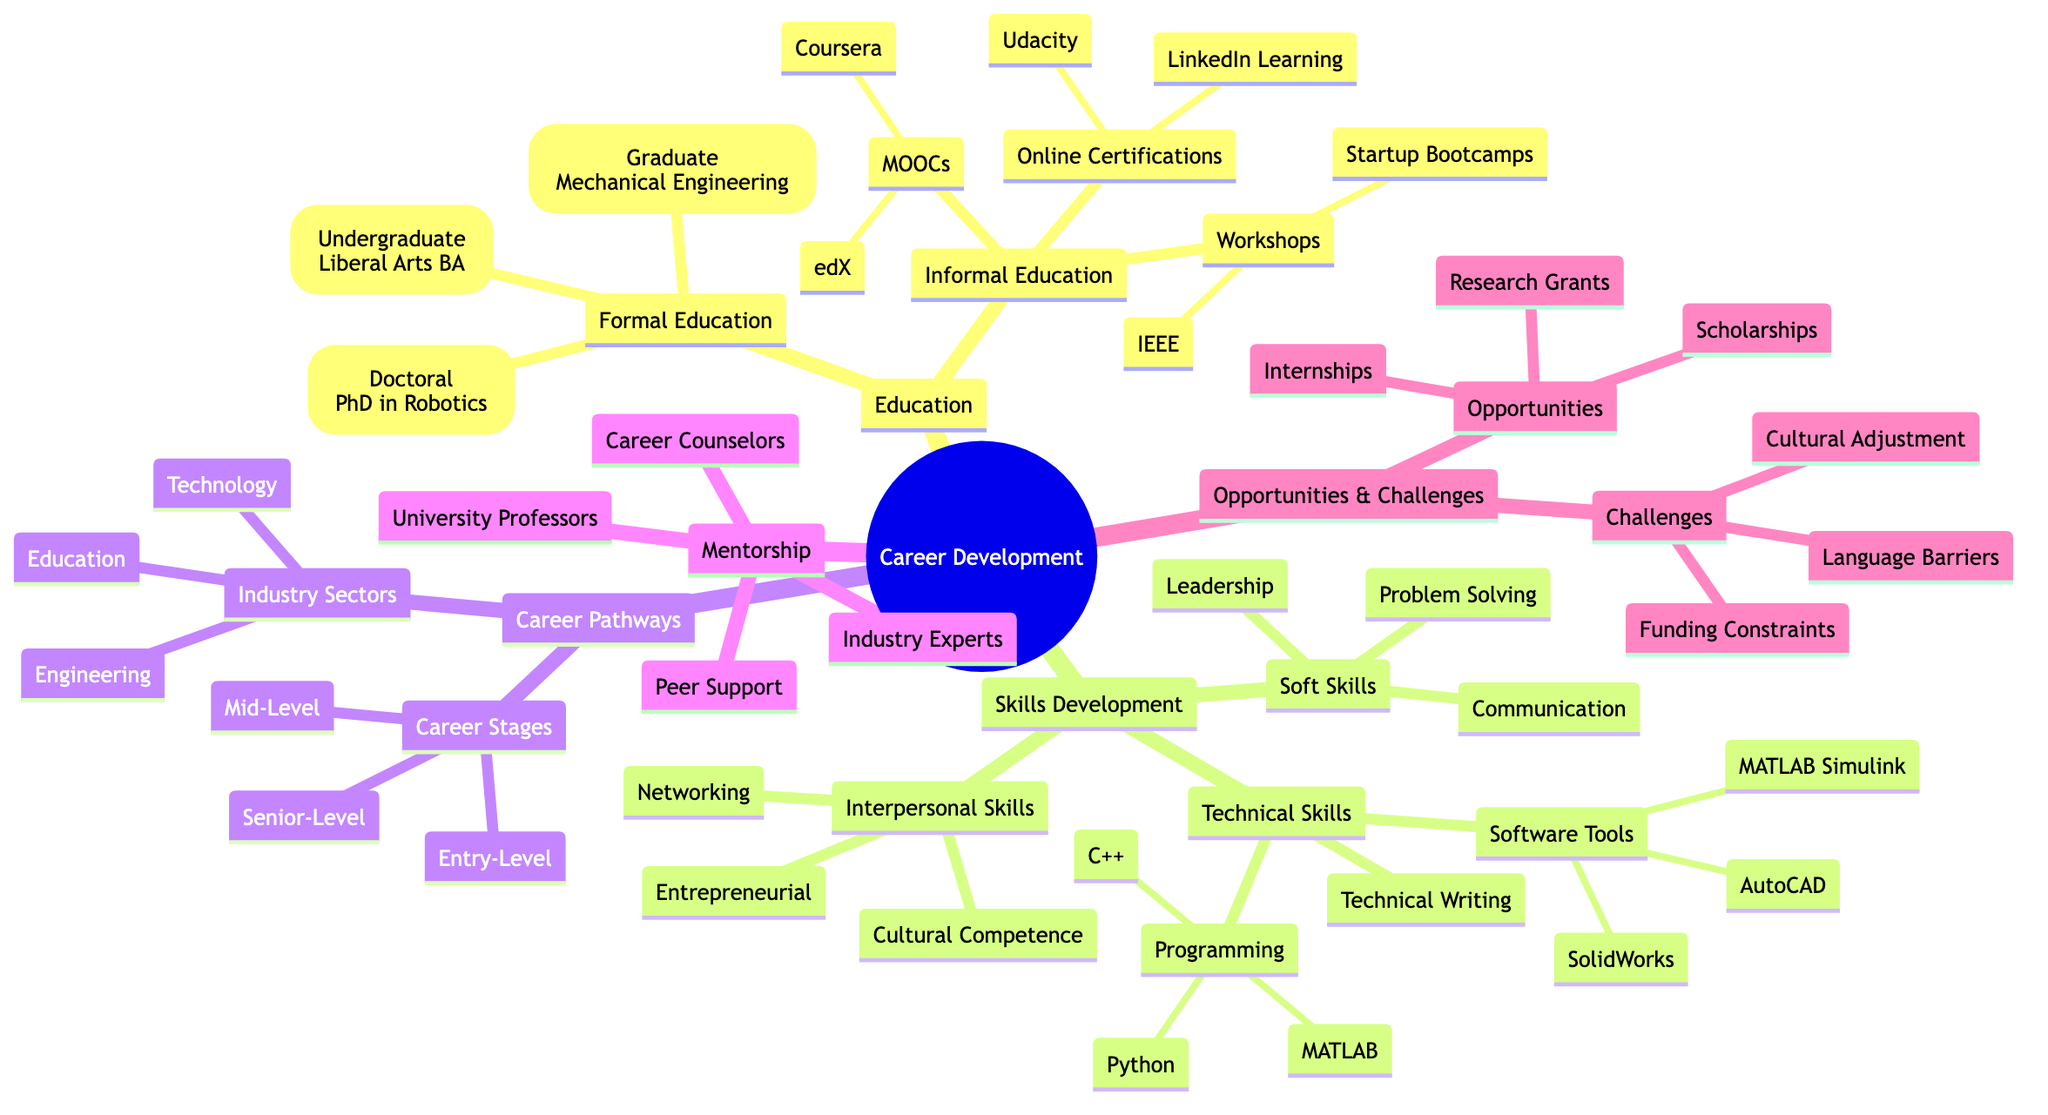What undergraduate degree is listed? The diagram specifies that the undergraduate degree is a Liberal Arts BA under the Formal Education section.
Answer: Liberal Arts BA How many programming languages are mentioned? Under the Technical Skills section, there are three programming languages listed: Python, C++, and MATLAB, which totals to three.
Answer: 3 What are the two types of education identified? The diagram highlights two main categories of education: Formal Education and Informal Education.
Answer: Formal Education and Informal Education What is a challenge faced in career development? The Opportunities and Challenges section includes several challenges, and one specific challenge listed is "Language Barriers."
Answer: Language Barriers Which career stage is indicated for entry-level jobs? The diagram categorizes entry-level jobs under Career Stages and lists "Junior Engineer" and "Technical Assistant" as examples.
Answer: Junior Engineer Which industry sector relates to AI Development? According to the Industry Sectors part of Career Pathways, AI Development is included under the Technology category.
Answer: Technology What type of support does a career counselor provide? Within the Mentorship and Guidance section, career counselors are described as providing guidance and support in career development, specifically through the University Career Services.
Answer: University Career Services How many soft skill categories are mentioned? The Skills Development section lists three categories of soft skills: Communication, Leadership, and Problem Solving, amounting to three categories.
Answer: 3 Who can be considered a mentor in this diagram? The Mentorship and Guidance section identifies mentors as University Professors and Industry Experts, both of whom play guidance roles in career pathways.
Answer: University Professors and Industry Experts 